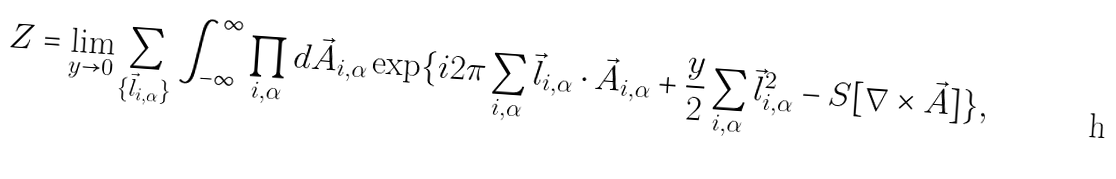<formula> <loc_0><loc_0><loc_500><loc_500>Z = \lim _ { y \rightarrow 0 } \sum _ { \{ \vec { l } _ { i , \alpha } \} } \int _ { - \infty } ^ { \infty } \prod _ { i , \alpha } d \vec { A } _ { i , \alpha } \exp \{ i 2 \pi \sum _ { i , \alpha } \vec { l } _ { i , \alpha } \cdot \vec { A } _ { i , \alpha } + \frac { y } { 2 } \sum _ { i , \alpha } \vec { l } _ { i , \alpha } ^ { 2 } - S [ \nabla \times \vec { A } ] \} ,</formula> 